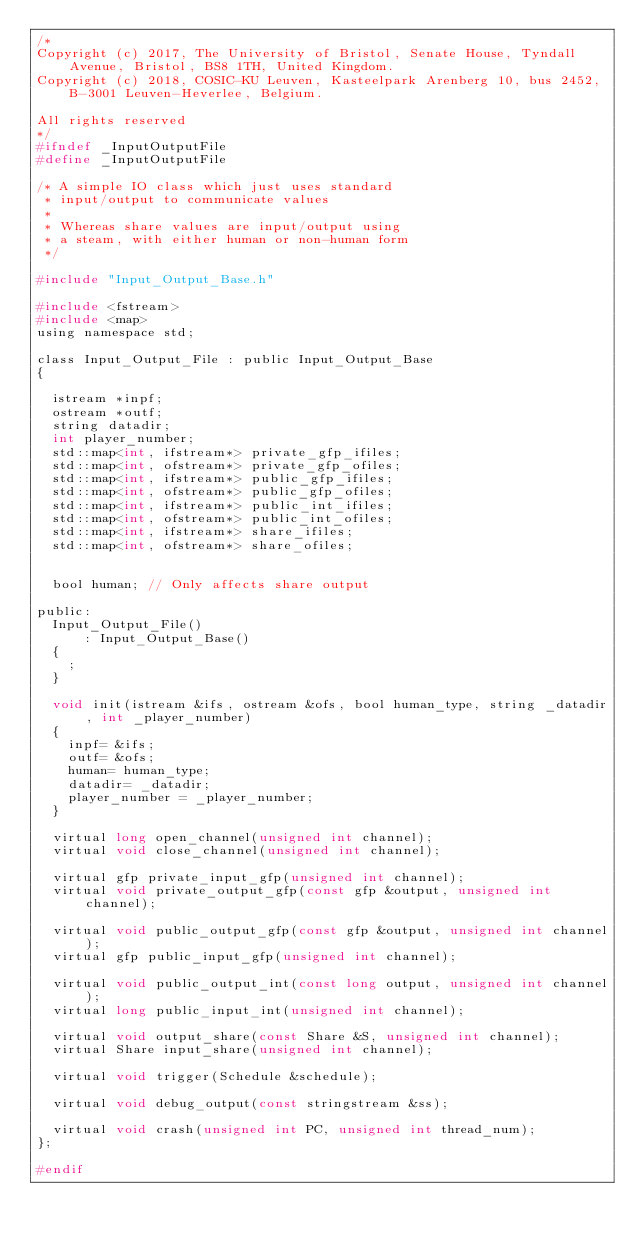<code> <loc_0><loc_0><loc_500><loc_500><_C_>/*
Copyright (c) 2017, The University of Bristol, Senate House, Tyndall Avenue, Bristol, BS8 1TH, United Kingdom.
Copyright (c) 2018, COSIC-KU Leuven, Kasteelpark Arenberg 10, bus 2452, B-3001 Leuven-Heverlee, Belgium.

All rights reserved
*/
#ifndef _InputOutputFile
#define _InputOutputFile

/* A simple IO class which just uses standard
 * input/output to communicate values
 *
 * Whereas share values are input/output using
 * a steam, with either human or non-human form
 */

#include "Input_Output_Base.h"

#include <fstream>
#include <map>
using namespace std;

class Input_Output_File : public Input_Output_Base
{

  istream *inpf;
  ostream *outf;
  string datadir;
  int player_number;
  std::map<int, ifstream*> private_gfp_ifiles;
  std::map<int, ofstream*> private_gfp_ofiles;
  std::map<int, ifstream*> public_gfp_ifiles;
  std::map<int, ofstream*> public_gfp_ofiles;
  std::map<int, ifstream*> public_int_ifiles;
  std::map<int, ofstream*> public_int_ofiles;
  std::map<int, ifstream*> share_ifiles;
  std::map<int, ofstream*> share_ofiles;


  bool human; // Only affects share output

public:
  Input_Output_File()
      : Input_Output_Base()
  {
    ;
  }

  void init(istream &ifs, ostream &ofs, bool human_type, string _datadir, int _player_number)
  {
    inpf= &ifs;
    outf= &ofs;
    human= human_type;
    datadir= _datadir;
    player_number = _player_number;
  }

  virtual long open_channel(unsigned int channel);
  virtual void close_channel(unsigned int channel);

  virtual gfp private_input_gfp(unsigned int channel);
  virtual void private_output_gfp(const gfp &output, unsigned int channel);

  virtual void public_output_gfp(const gfp &output, unsigned int channel);
  virtual gfp public_input_gfp(unsigned int channel);

  virtual void public_output_int(const long output, unsigned int channel);
  virtual long public_input_int(unsigned int channel);

  virtual void output_share(const Share &S, unsigned int channel);
  virtual Share input_share(unsigned int channel);

  virtual void trigger(Schedule &schedule);

  virtual void debug_output(const stringstream &ss);

  virtual void crash(unsigned int PC, unsigned int thread_num);
};

#endif
</code> 